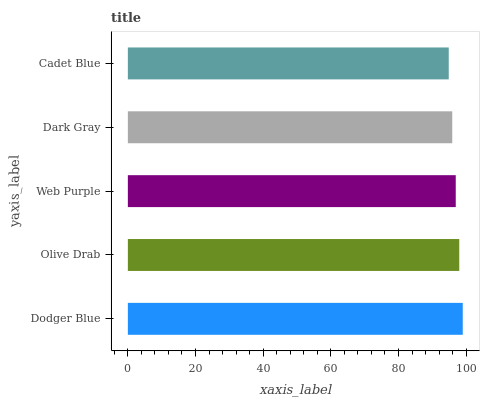Is Cadet Blue the minimum?
Answer yes or no. Yes. Is Dodger Blue the maximum?
Answer yes or no. Yes. Is Olive Drab the minimum?
Answer yes or no. No. Is Olive Drab the maximum?
Answer yes or no. No. Is Dodger Blue greater than Olive Drab?
Answer yes or no. Yes. Is Olive Drab less than Dodger Blue?
Answer yes or no. Yes. Is Olive Drab greater than Dodger Blue?
Answer yes or no. No. Is Dodger Blue less than Olive Drab?
Answer yes or no. No. Is Web Purple the high median?
Answer yes or no. Yes. Is Web Purple the low median?
Answer yes or no. Yes. Is Dodger Blue the high median?
Answer yes or no. No. Is Dark Gray the low median?
Answer yes or no. No. 